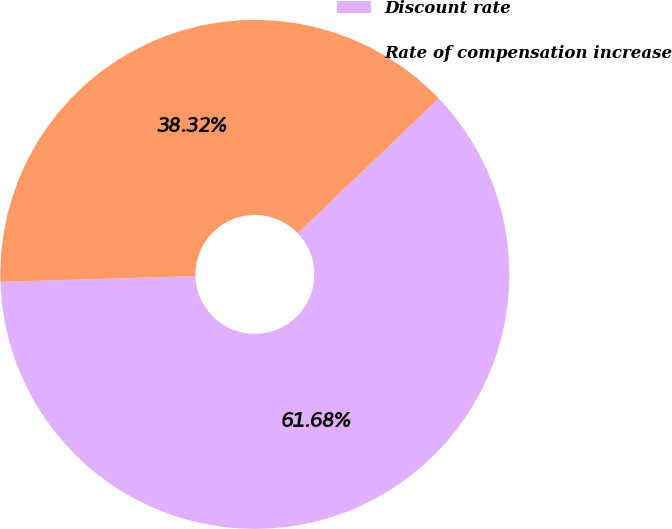Convert chart. <chart><loc_0><loc_0><loc_500><loc_500><pie_chart><fcel>Discount rate<fcel>Rate of compensation increase<nl><fcel>61.68%<fcel>38.32%<nl></chart> 